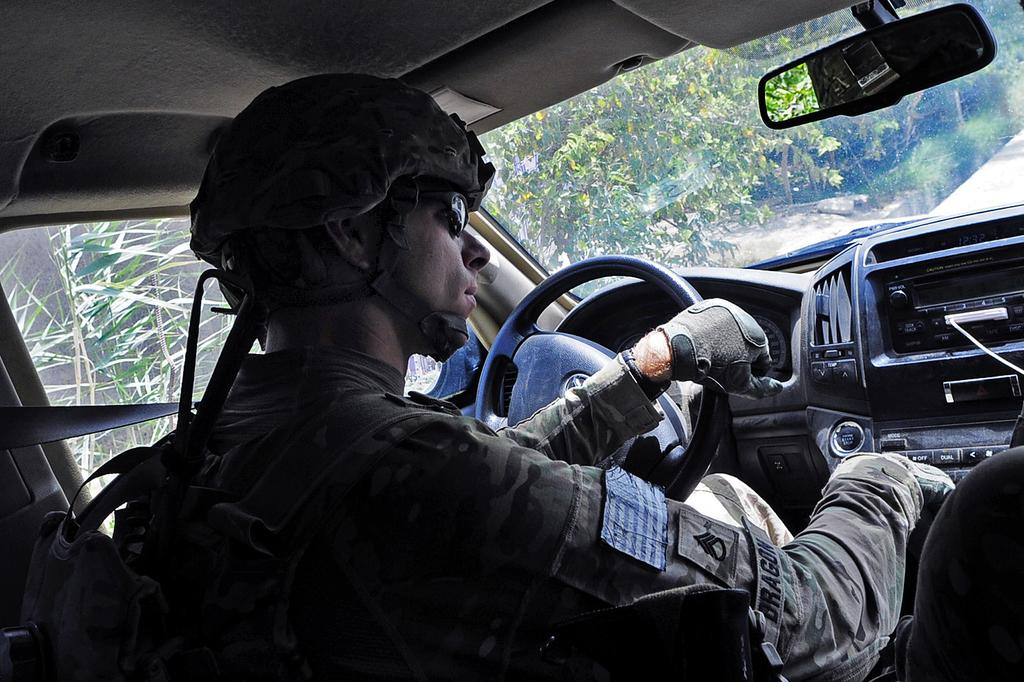What is the man in the image doing? The man is sitting in a car. What protective gear is the man wearing? The man is wearing a helmet, hand gloves, and sunglasses. What can be seen inside the car? There is a front mirror in the car. What is visible in the background of the image? There are trees visible in the image. What news is the man reading in the image? There is no news visible in the image; the man is wearing sunglasses and not reading anything. 